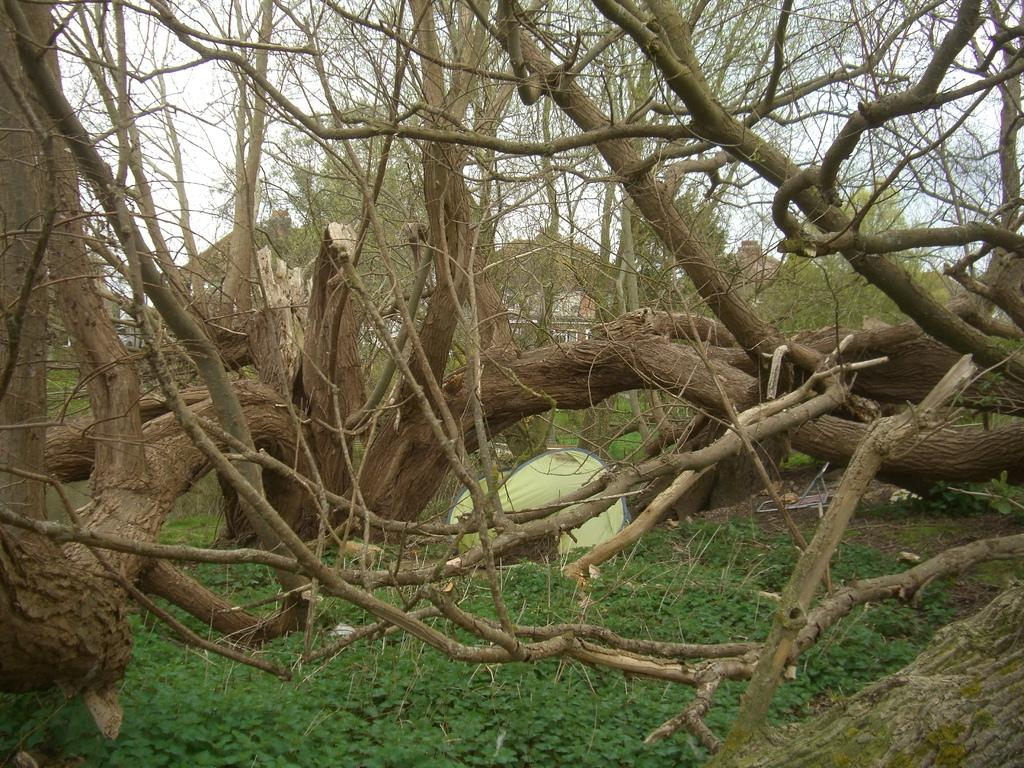What type of vegetation can be seen in the image? There are trees in the image. What other natural elements are present in the image? There is grass in the image. What type of soup is being served in the image? There is no soup present in the image; it only features trees and grass. How many deer can be seen in the image? There are no deer present in the image; it only features trees and grass. 